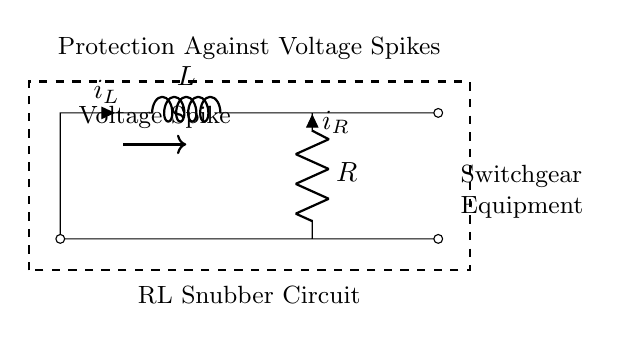What type of circuit is shown here? This is an RL snubber circuit, which consists of a resistor and an inductor used for absorbing voltage spikes. The visual representation shows the inductor (L) and resistor (R) directly connected in a series configuration.
Answer: RL snubber circuit What components are present in the circuit? The circuit contains an inductor and a resistor. These components are explicitly labeled in the diagram, with the inductor denoted as L and the resistor as R.
Answer: Inductor and resistor What does the voltage spike arrow indicate? The arrow labeled "Voltage Spike" shows the direction of the transient event that the snubber circuit is designed to mitigate. The visual depiction highlights the risks associated with switchgear, which is also mentioned in the diagram.
Answer: Voltage spike What is the role of the resistor in this circuit? The resistor is intended to limit the current and dissipate energy when a voltage spike occurs. This function helps to protect the circuit and connected equipment by preventing excessive current flow.
Answer: Current limitation and energy dissipation How does the inductor respond to a voltage spike? The inductor resists changes in current due to its stored magnetic energy. When a voltage spike occurs, it generates a back electromotive force, which counters rapid changes in current, thus providing protection.
Answer: Resists current change What is the function of the dashed rectangle in the circuit? The dashed rectangle encloses the entire snubber circuit, indicating its entirety as a protective component. It serves to visually separate the circuit from other parts of the overall system and emphasizes its function of protection.
Answer: Encapsulation for protection 